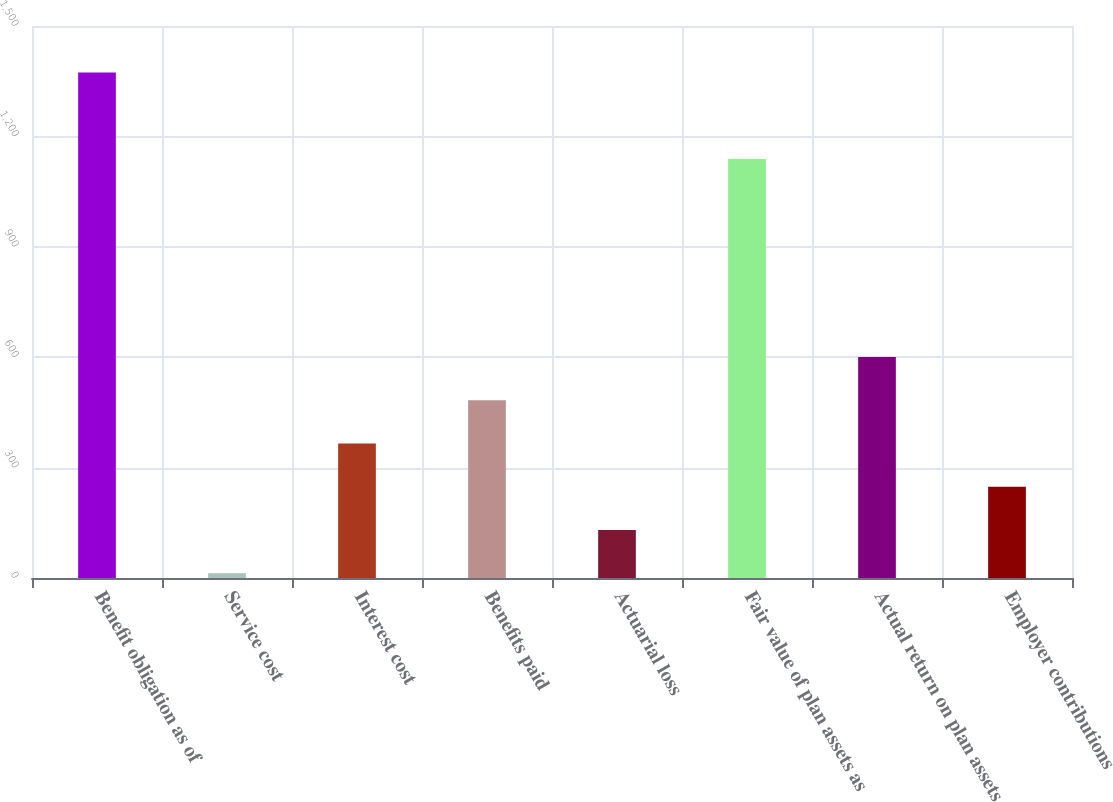Convert chart to OTSL. <chart><loc_0><loc_0><loc_500><loc_500><bar_chart><fcel>Benefit obligation as of<fcel>Service cost<fcel>Interest cost<fcel>Benefits paid<fcel>Actuarial loss<fcel>Fair value of plan assets as<fcel>Actual return on plan assets<fcel>Employer contributions<nl><fcel>1373.5<fcel>13<fcel>365.5<fcel>483<fcel>130.5<fcel>1138.5<fcel>600.5<fcel>248<nl></chart> 